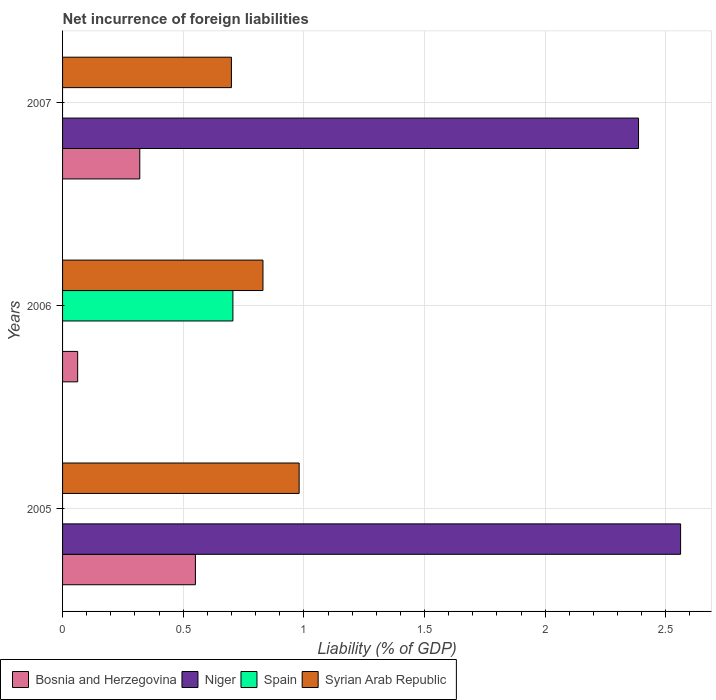How many groups of bars are there?
Your answer should be very brief. 3. Are the number of bars on each tick of the Y-axis equal?
Your response must be concise. Yes. How many bars are there on the 1st tick from the top?
Give a very brief answer. 3. What is the net incurrence of foreign liabilities in Syrian Arab Republic in 2007?
Your response must be concise. 0.7. Across all years, what is the maximum net incurrence of foreign liabilities in Spain?
Keep it short and to the point. 0.71. Across all years, what is the minimum net incurrence of foreign liabilities in Bosnia and Herzegovina?
Provide a succinct answer. 0.06. In which year was the net incurrence of foreign liabilities in Bosnia and Herzegovina maximum?
Provide a succinct answer. 2005. What is the total net incurrence of foreign liabilities in Spain in the graph?
Keep it short and to the point. 0.71. What is the difference between the net incurrence of foreign liabilities in Syrian Arab Republic in 2005 and that in 2006?
Ensure brevity in your answer.  0.15. What is the difference between the net incurrence of foreign liabilities in Syrian Arab Republic in 2006 and the net incurrence of foreign liabilities in Niger in 2007?
Ensure brevity in your answer.  -1.56. What is the average net incurrence of foreign liabilities in Spain per year?
Offer a very short reply. 0.24. In the year 2005, what is the difference between the net incurrence of foreign liabilities in Niger and net incurrence of foreign liabilities in Bosnia and Herzegovina?
Make the answer very short. 2.01. What is the ratio of the net incurrence of foreign liabilities in Syrian Arab Republic in 2005 to that in 2006?
Your response must be concise. 1.18. Is the difference between the net incurrence of foreign liabilities in Niger in 2005 and 2007 greater than the difference between the net incurrence of foreign liabilities in Bosnia and Herzegovina in 2005 and 2007?
Your response must be concise. No. What is the difference between the highest and the second highest net incurrence of foreign liabilities in Bosnia and Herzegovina?
Provide a short and direct response. 0.23. What is the difference between the highest and the lowest net incurrence of foreign liabilities in Spain?
Make the answer very short. 0.71. Is the sum of the net incurrence of foreign liabilities in Bosnia and Herzegovina in 2005 and 2006 greater than the maximum net incurrence of foreign liabilities in Spain across all years?
Ensure brevity in your answer.  No. Is it the case that in every year, the sum of the net incurrence of foreign liabilities in Spain and net incurrence of foreign liabilities in Bosnia and Herzegovina is greater than the sum of net incurrence of foreign liabilities in Syrian Arab Republic and net incurrence of foreign liabilities in Niger?
Make the answer very short. No. Is it the case that in every year, the sum of the net incurrence of foreign liabilities in Niger and net incurrence of foreign liabilities in Spain is greater than the net incurrence of foreign liabilities in Syrian Arab Republic?
Ensure brevity in your answer.  No. Are all the bars in the graph horizontal?
Your response must be concise. Yes. Are the values on the major ticks of X-axis written in scientific E-notation?
Ensure brevity in your answer.  No. Does the graph contain grids?
Provide a succinct answer. Yes. How are the legend labels stacked?
Offer a terse response. Horizontal. What is the title of the graph?
Offer a terse response. Net incurrence of foreign liabilities. Does "Chile" appear as one of the legend labels in the graph?
Give a very brief answer. No. What is the label or title of the X-axis?
Your answer should be compact. Liability (% of GDP). What is the label or title of the Y-axis?
Provide a succinct answer. Years. What is the Liability (% of GDP) in Bosnia and Herzegovina in 2005?
Ensure brevity in your answer.  0.55. What is the Liability (% of GDP) of Niger in 2005?
Offer a terse response. 2.56. What is the Liability (% of GDP) in Syrian Arab Republic in 2005?
Your response must be concise. 0.98. What is the Liability (% of GDP) of Bosnia and Herzegovina in 2006?
Give a very brief answer. 0.06. What is the Liability (% of GDP) in Spain in 2006?
Make the answer very short. 0.71. What is the Liability (% of GDP) of Syrian Arab Republic in 2006?
Offer a terse response. 0.83. What is the Liability (% of GDP) in Bosnia and Herzegovina in 2007?
Offer a very short reply. 0.32. What is the Liability (% of GDP) in Niger in 2007?
Offer a very short reply. 2.39. What is the Liability (% of GDP) of Spain in 2007?
Your answer should be very brief. 0. What is the Liability (% of GDP) in Syrian Arab Republic in 2007?
Keep it short and to the point. 0.7. Across all years, what is the maximum Liability (% of GDP) in Bosnia and Herzegovina?
Keep it short and to the point. 0.55. Across all years, what is the maximum Liability (% of GDP) in Niger?
Provide a succinct answer. 2.56. Across all years, what is the maximum Liability (% of GDP) in Spain?
Keep it short and to the point. 0.71. Across all years, what is the maximum Liability (% of GDP) of Syrian Arab Republic?
Your answer should be compact. 0.98. Across all years, what is the minimum Liability (% of GDP) of Bosnia and Herzegovina?
Give a very brief answer. 0.06. Across all years, what is the minimum Liability (% of GDP) in Niger?
Offer a terse response. 0. Across all years, what is the minimum Liability (% of GDP) in Syrian Arab Republic?
Offer a terse response. 0.7. What is the total Liability (% of GDP) of Bosnia and Herzegovina in the graph?
Ensure brevity in your answer.  0.93. What is the total Liability (% of GDP) in Niger in the graph?
Your response must be concise. 4.95. What is the total Liability (% of GDP) of Spain in the graph?
Keep it short and to the point. 0.71. What is the total Liability (% of GDP) in Syrian Arab Republic in the graph?
Provide a succinct answer. 2.51. What is the difference between the Liability (% of GDP) of Bosnia and Herzegovina in 2005 and that in 2006?
Your answer should be compact. 0.49. What is the difference between the Liability (% of GDP) of Syrian Arab Republic in 2005 and that in 2006?
Provide a short and direct response. 0.15. What is the difference between the Liability (% of GDP) of Bosnia and Herzegovina in 2005 and that in 2007?
Your answer should be compact. 0.23. What is the difference between the Liability (% of GDP) of Niger in 2005 and that in 2007?
Keep it short and to the point. 0.17. What is the difference between the Liability (% of GDP) of Syrian Arab Republic in 2005 and that in 2007?
Your answer should be very brief. 0.28. What is the difference between the Liability (% of GDP) in Bosnia and Herzegovina in 2006 and that in 2007?
Your answer should be compact. -0.26. What is the difference between the Liability (% of GDP) of Syrian Arab Republic in 2006 and that in 2007?
Offer a terse response. 0.13. What is the difference between the Liability (% of GDP) of Bosnia and Herzegovina in 2005 and the Liability (% of GDP) of Spain in 2006?
Ensure brevity in your answer.  -0.16. What is the difference between the Liability (% of GDP) in Bosnia and Herzegovina in 2005 and the Liability (% of GDP) in Syrian Arab Republic in 2006?
Provide a succinct answer. -0.28. What is the difference between the Liability (% of GDP) in Niger in 2005 and the Liability (% of GDP) in Spain in 2006?
Offer a terse response. 1.86. What is the difference between the Liability (% of GDP) of Niger in 2005 and the Liability (% of GDP) of Syrian Arab Republic in 2006?
Your answer should be compact. 1.73. What is the difference between the Liability (% of GDP) in Bosnia and Herzegovina in 2005 and the Liability (% of GDP) in Niger in 2007?
Your response must be concise. -1.84. What is the difference between the Liability (% of GDP) of Bosnia and Herzegovina in 2005 and the Liability (% of GDP) of Syrian Arab Republic in 2007?
Your answer should be compact. -0.15. What is the difference between the Liability (% of GDP) in Niger in 2005 and the Liability (% of GDP) in Syrian Arab Republic in 2007?
Offer a very short reply. 1.86. What is the difference between the Liability (% of GDP) of Bosnia and Herzegovina in 2006 and the Liability (% of GDP) of Niger in 2007?
Offer a very short reply. -2.32. What is the difference between the Liability (% of GDP) in Bosnia and Herzegovina in 2006 and the Liability (% of GDP) in Syrian Arab Republic in 2007?
Provide a succinct answer. -0.64. What is the difference between the Liability (% of GDP) in Spain in 2006 and the Liability (% of GDP) in Syrian Arab Republic in 2007?
Provide a succinct answer. 0.01. What is the average Liability (% of GDP) of Bosnia and Herzegovina per year?
Your answer should be compact. 0.31. What is the average Liability (% of GDP) of Niger per year?
Provide a short and direct response. 1.65. What is the average Liability (% of GDP) of Spain per year?
Your answer should be compact. 0.24. What is the average Liability (% of GDP) in Syrian Arab Republic per year?
Provide a succinct answer. 0.84. In the year 2005, what is the difference between the Liability (% of GDP) of Bosnia and Herzegovina and Liability (% of GDP) of Niger?
Your answer should be very brief. -2.01. In the year 2005, what is the difference between the Liability (% of GDP) in Bosnia and Herzegovina and Liability (% of GDP) in Syrian Arab Republic?
Your response must be concise. -0.43. In the year 2005, what is the difference between the Liability (% of GDP) of Niger and Liability (% of GDP) of Syrian Arab Republic?
Your answer should be compact. 1.58. In the year 2006, what is the difference between the Liability (% of GDP) of Bosnia and Herzegovina and Liability (% of GDP) of Spain?
Make the answer very short. -0.64. In the year 2006, what is the difference between the Liability (% of GDP) of Bosnia and Herzegovina and Liability (% of GDP) of Syrian Arab Republic?
Give a very brief answer. -0.77. In the year 2006, what is the difference between the Liability (% of GDP) of Spain and Liability (% of GDP) of Syrian Arab Republic?
Your answer should be very brief. -0.12. In the year 2007, what is the difference between the Liability (% of GDP) in Bosnia and Herzegovina and Liability (% of GDP) in Niger?
Your answer should be very brief. -2.07. In the year 2007, what is the difference between the Liability (% of GDP) of Bosnia and Herzegovina and Liability (% of GDP) of Syrian Arab Republic?
Make the answer very short. -0.38. In the year 2007, what is the difference between the Liability (% of GDP) of Niger and Liability (% of GDP) of Syrian Arab Republic?
Keep it short and to the point. 1.69. What is the ratio of the Liability (% of GDP) of Bosnia and Herzegovina in 2005 to that in 2006?
Offer a very short reply. 8.79. What is the ratio of the Liability (% of GDP) in Syrian Arab Republic in 2005 to that in 2006?
Offer a terse response. 1.18. What is the ratio of the Liability (% of GDP) in Bosnia and Herzegovina in 2005 to that in 2007?
Provide a short and direct response. 1.72. What is the ratio of the Liability (% of GDP) in Niger in 2005 to that in 2007?
Provide a short and direct response. 1.07. What is the ratio of the Liability (% of GDP) of Syrian Arab Republic in 2005 to that in 2007?
Your answer should be compact. 1.4. What is the ratio of the Liability (% of GDP) of Bosnia and Herzegovina in 2006 to that in 2007?
Give a very brief answer. 0.2. What is the ratio of the Liability (% of GDP) of Syrian Arab Republic in 2006 to that in 2007?
Ensure brevity in your answer.  1.19. What is the difference between the highest and the second highest Liability (% of GDP) in Bosnia and Herzegovina?
Provide a succinct answer. 0.23. What is the difference between the highest and the second highest Liability (% of GDP) of Syrian Arab Republic?
Keep it short and to the point. 0.15. What is the difference between the highest and the lowest Liability (% of GDP) of Bosnia and Herzegovina?
Provide a short and direct response. 0.49. What is the difference between the highest and the lowest Liability (% of GDP) in Niger?
Your response must be concise. 2.56. What is the difference between the highest and the lowest Liability (% of GDP) in Spain?
Keep it short and to the point. 0.71. What is the difference between the highest and the lowest Liability (% of GDP) of Syrian Arab Republic?
Your response must be concise. 0.28. 